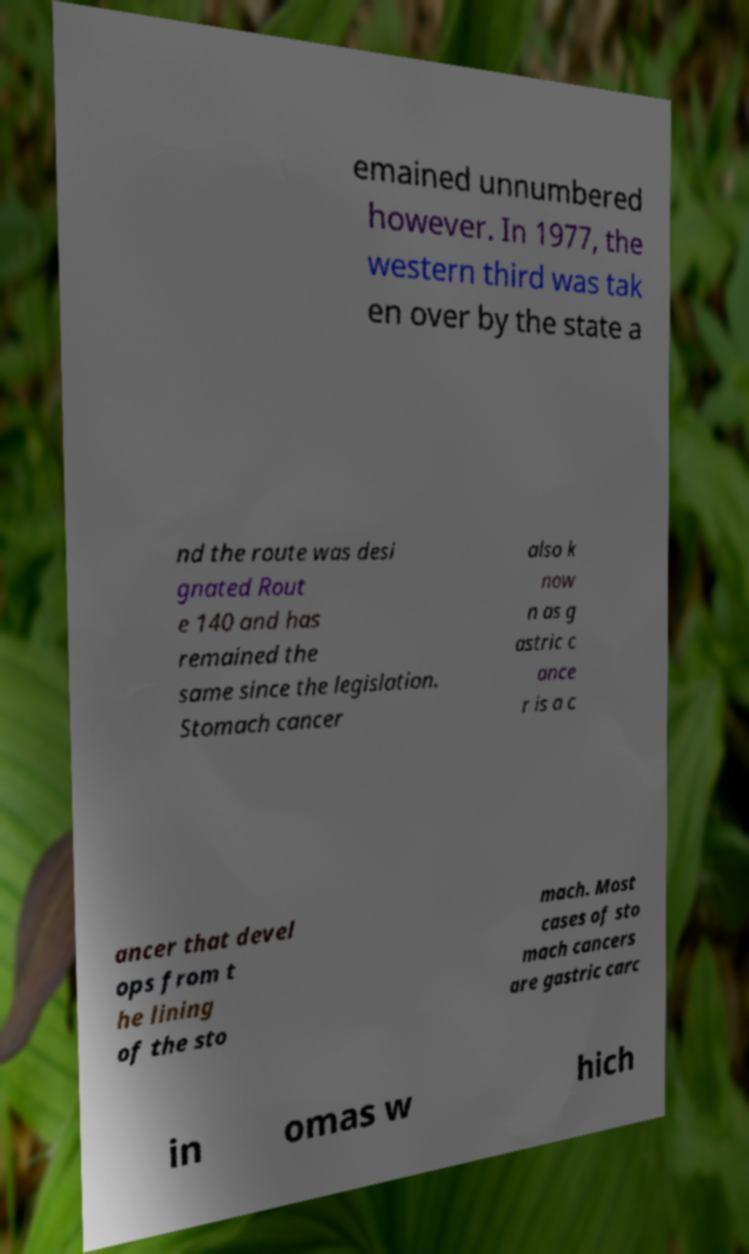Please identify and transcribe the text found in this image. emained unnumbered however. In 1977, the western third was tak en over by the state a nd the route was desi gnated Rout e 140 and has remained the same since the legislation. Stomach cancer also k now n as g astric c ance r is a c ancer that devel ops from t he lining of the sto mach. Most cases of sto mach cancers are gastric carc in omas w hich 